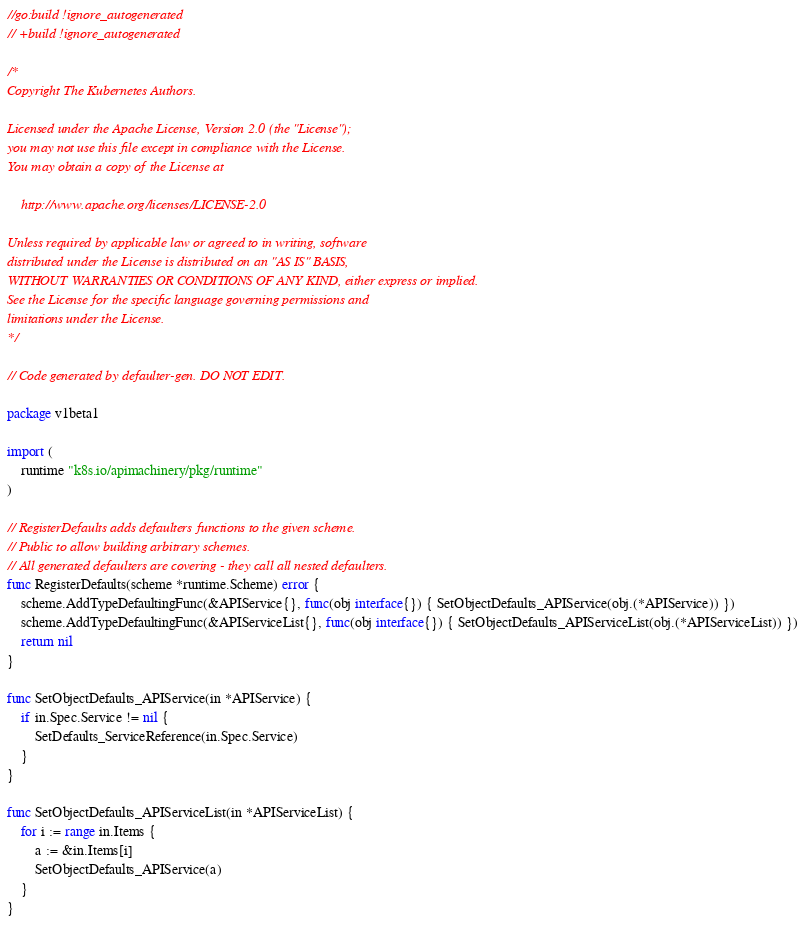<code> <loc_0><loc_0><loc_500><loc_500><_Go_>//go:build !ignore_autogenerated
// +build !ignore_autogenerated

/*
Copyright The Kubernetes Authors.

Licensed under the Apache License, Version 2.0 (the "License");
you may not use this file except in compliance with the License.
You may obtain a copy of the License at

    http://www.apache.org/licenses/LICENSE-2.0

Unless required by applicable law or agreed to in writing, software
distributed under the License is distributed on an "AS IS" BASIS,
WITHOUT WARRANTIES OR CONDITIONS OF ANY KIND, either express or implied.
See the License for the specific language governing permissions and
limitations under the License.
*/

// Code generated by defaulter-gen. DO NOT EDIT.

package v1beta1

import (
	runtime "k8s.io/apimachinery/pkg/runtime"
)

// RegisterDefaults adds defaulters functions to the given scheme.
// Public to allow building arbitrary schemes.
// All generated defaulters are covering - they call all nested defaulters.
func RegisterDefaults(scheme *runtime.Scheme) error {
	scheme.AddTypeDefaultingFunc(&APIService{}, func(obj interface{}) { SetObjectDefaults_APIService(obj.(*APIService)) })
	scheme.AddTypeDefaultingFunc(&APIServiceList{}, func(obj interface{}) { SetObjectDefaults_APIServiceList(obj.(*APIServiceList)) })
	return nil
}

func SetObjectDefaults_APIService(in *APIService) {
	if in.Spec.Service != nil {
		SetDefaults_ServiceReference(in.Spec.Service)
	}
}

func SetObjectDefaults_APIServiceList(in *APIServiceList) {
	for i := range in.Items {
		a := &in.Items[i]
		SetObjectDefaults_APIService(a)
	}
}
</code> 